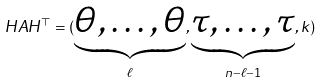Convert formula to latex. <formula><loc_0><loc_0><loc_500><loc_500>H A H ^ { \top } = ( \underbrace { \theta , \dots , \theta } _ { \ell } , \underbrace { \tau , \dots , \tau } _ { n - \ell - 1 } , k )</formula> 